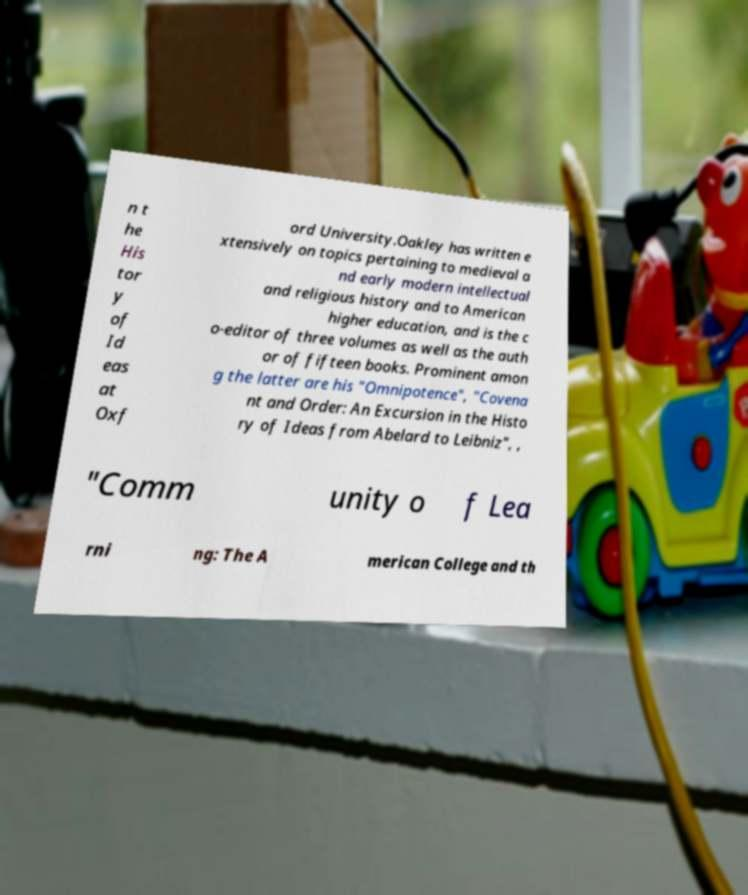Can you read and provide the text displayed in the image?This photo seems to have some interesting text. Can you extract and type it out for me? n t he His tor y of Id eas at Oxf ord University.Oakley has written e xtensively on topics pertaining to medieval a nd early modern intellectual and religious history and to American higher education, and is the c o-editor of three volumes as well as the auth or of fifteen books. Prominent amon g the latter are his "Omnipotence", "Covena nt and Order: An Excursion in the Histo ry of Ideas from Abelard to Leibniz", , "Comm unity o f Lea rni ng: The A merican College and th 